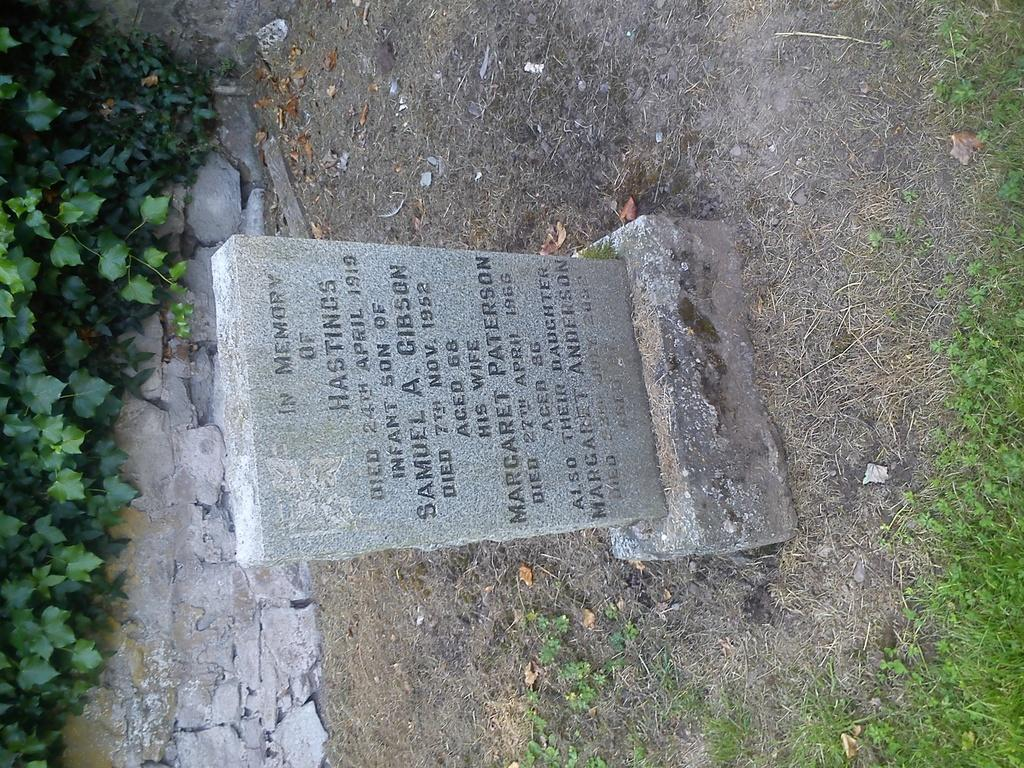What is the color of the stone in the image? The stone in the image is grey-colored. What is written on the stone? Something is written on the stone. What type of vegetation can be seen in the image? Grass is visible in the image. What color are the leaves present in the image? The leaves in the image are green-colored. How does the pollution affect the stone in the image? There is no indication of pollution in the image, so we cannot determine its effect on the stone. 